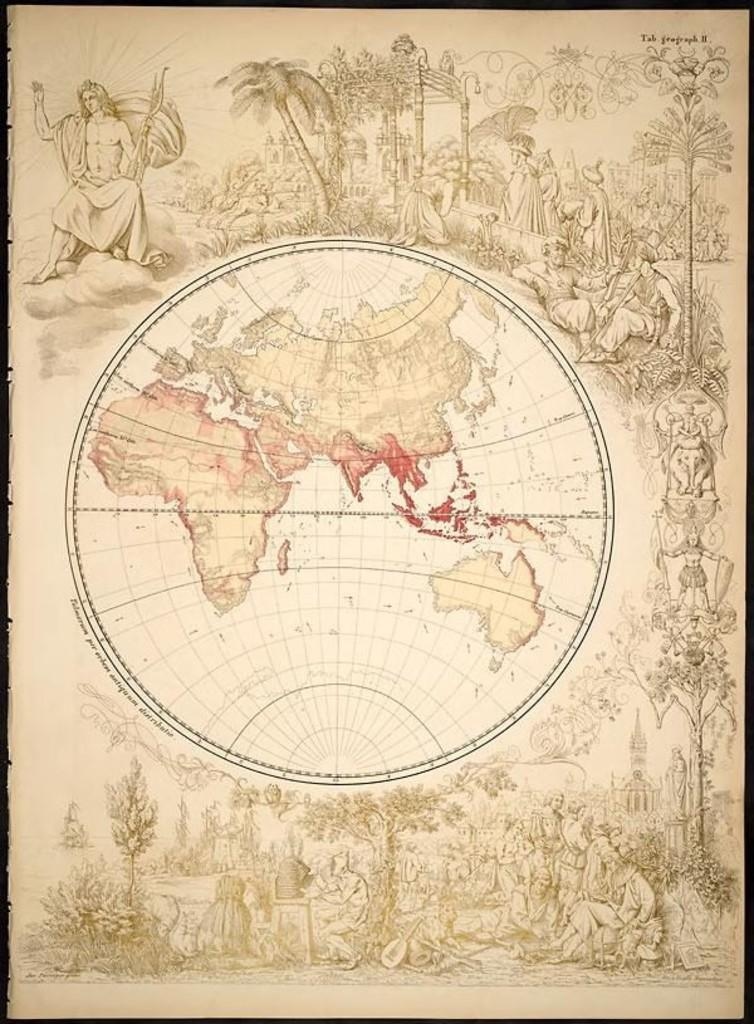What is the main object in the image? There is a poster in the image. What can be seen at the top of the poster? The poster has a blob at the top. What can be seen at the bottom of the poster? The poster has a blob at the bottom. What types of images are on the poster? There are images of people and trees on the poster. How many grapes are hanging from the tree in the image? There are no grapes or trees in the image; the poster only has images of trees, not actual trees. What type of heart is depicted in the image? There is no heart present in the image; the poster only has images of people and trees. 